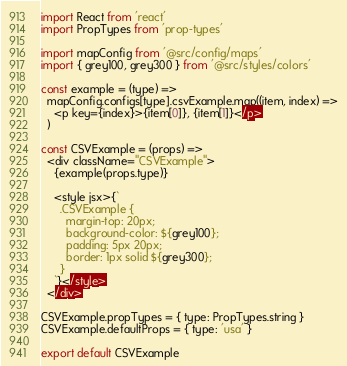<code> <loc_0><loc_0><loc_500><loc_500><_JavaScript_>import React from 'react'
import PropTypes from 'prop-types'

import mapConfig from '@src/config/maps'
import { grey100, grey300 } from '@src/styles/colors'

const example = (type) =>
  mapConfig.configs[type].csvExample.map((item, index) =>
    <p key={index}>{item[0]}, {item[1]}</p>
  )

const CSVExample = (props) =>
  <div className="CSVExample">
    {example(props.type)}

    <style jsx>{`
      .CSVExample {
        margin-top: 20px;
        background-color: ${grey100};
        padding: 5px 20px;
        border: 1px solid ${grey300};
      }
    `}</style>
  </div>

CSVExample.propTypes = { type: PropTypes.string }
CSVExample.defaultProps = { type: 'usa' }

export default CSVExample
</code> 